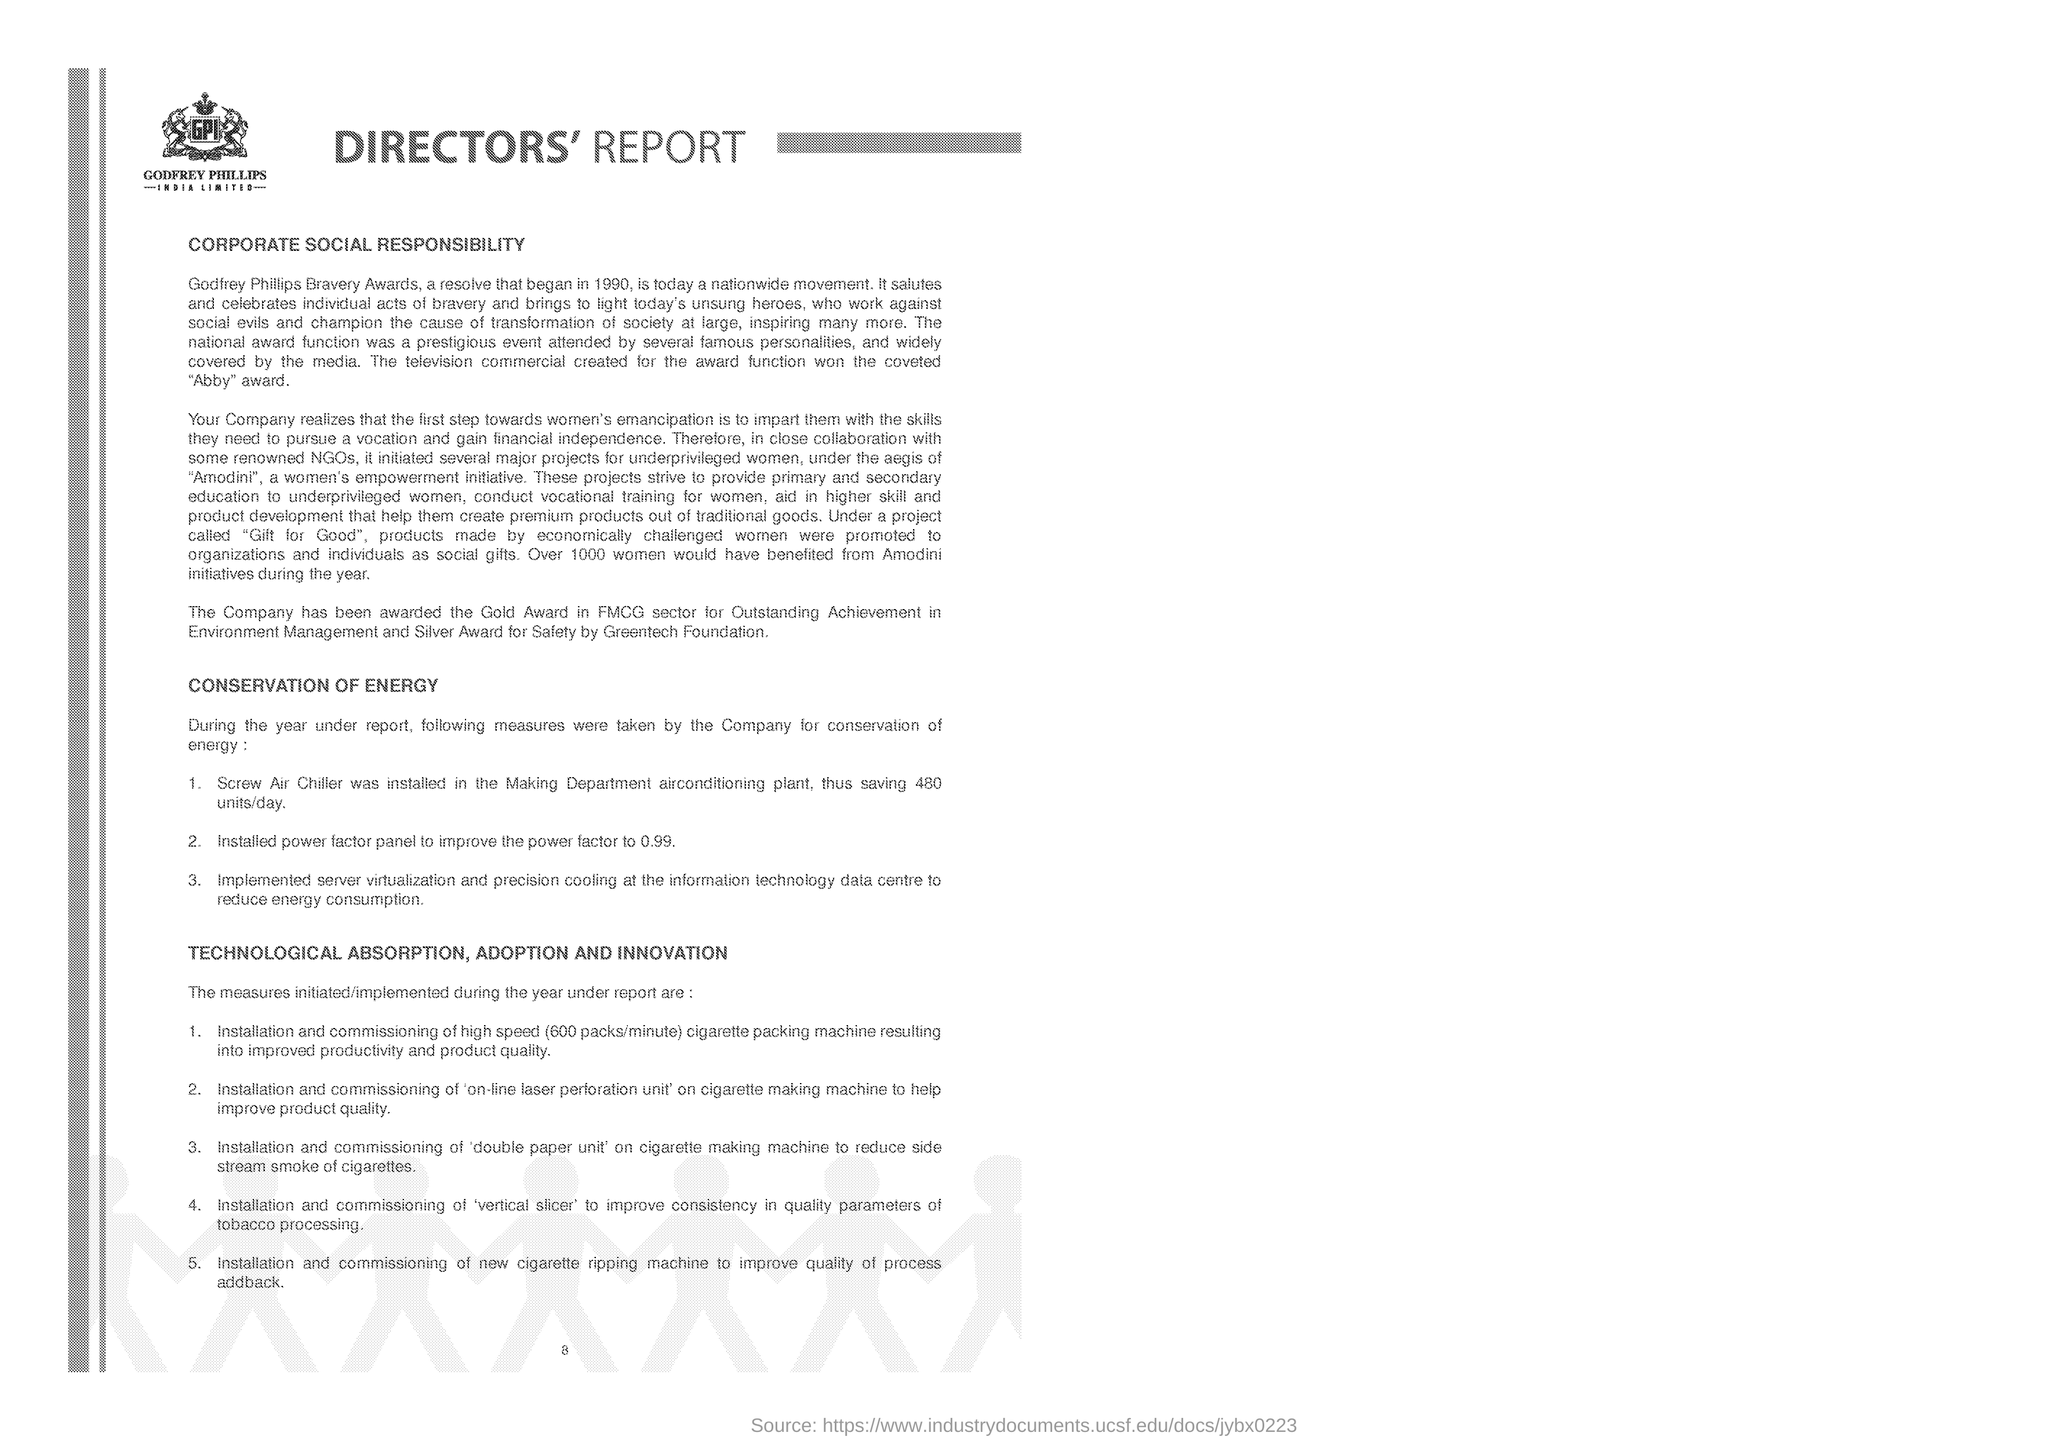Which company is mentioned in the logo?
Offer a terse response. GPI. In which year is GODFREY PHILLIPS BRAVERY AWARD began?
Ensure brevity in your answer.  1990. Why the company was awarded the Gold Award in FMCG sector?
Provide a succinct answer. For outstanding achievement in Environment Management. How many units/day can be saved by installing Screw Air Chiller in the Making Department air conditioning plant?
Provide a short and direct response. 480. What is installed to improve consistency in quality parameters of tobacco processing?
Offer a terse response. 'vertical slicer'. 